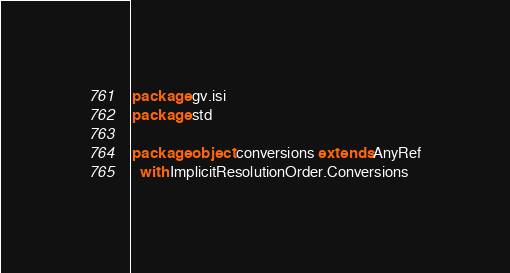<code> <loc_0><loc_0><loc_500><loc_500><_Scala_>package gv.isi
package std

package object conversions extends AnyRef
  with ImplicitResolutionOrder.Conversions
</code> 